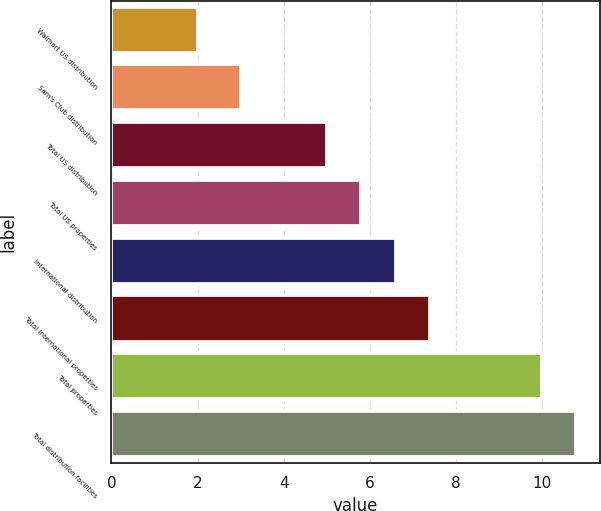Convert chart to OTSL. <chart><loc_0><loc_0><loc_500><loc_500><bar_chart><fcel>Walmart US distribution<fcel>Sam's Club distribution<fcel>Total US distribution<fcel>Total US properties<fcel>International distribution<fcel>Total International properties<fcel>Total properties<fcel>Total distribution facilities<nl><fcel>2<fcel>3<fcel>5<fcel>5.8<fcel>6.6<fcel>7.4<fcel>10<fcel>10.8<nl></chart> 